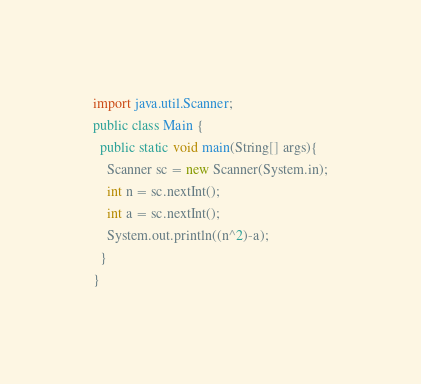Convert code to text. <code><loc_0><loc_0><loc_500><loc_500><_Java_>import java.util.Scanner;
public class Main {
  public static void main(String[] args){
    Scanner sc = new Scanner(System.in);
    int n = sc.nextInt();
    int a = sc.nextInt();
    System.out.println((n^2)-a);
  }
}</code> 